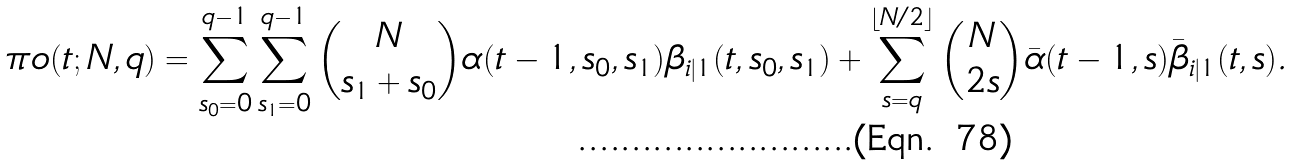<formula> <loc_0><loc_0><loc_500><loc_500>& \pi o ( t ; N , q ) = \sum _ { s _ { 0 } = 0 } ^ { q - 1 } \sum _ { s _ { 1 } = 0 } ^ { q - 1 } { N \choose s _ { 1 } + s _ { 0 } } \alpha ( t - 1 , s _ { 0 } , s _ { 1 } ) \beta _ { i | 1 } ( t , s _ { 0 } , s _ { 1 } ) + \sum _ { s = q } ^ { \lfloor N / 2 \rfloor } { N \choose 2 s } \bar { \alpha } ( t - 1 , s ) \bar { \beta } _ { i | 1 } ( t , s ) .</formula> 